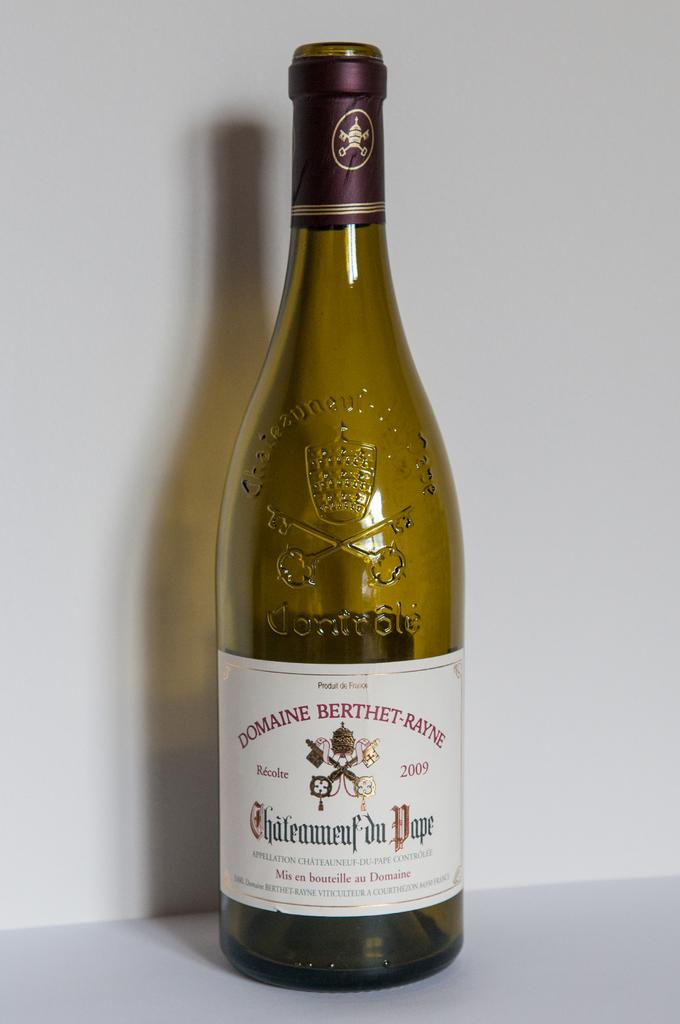Provide a one-sentence caption for the provided image. A empty bottle of Domaine Berthet-rayne wine stands alone. 